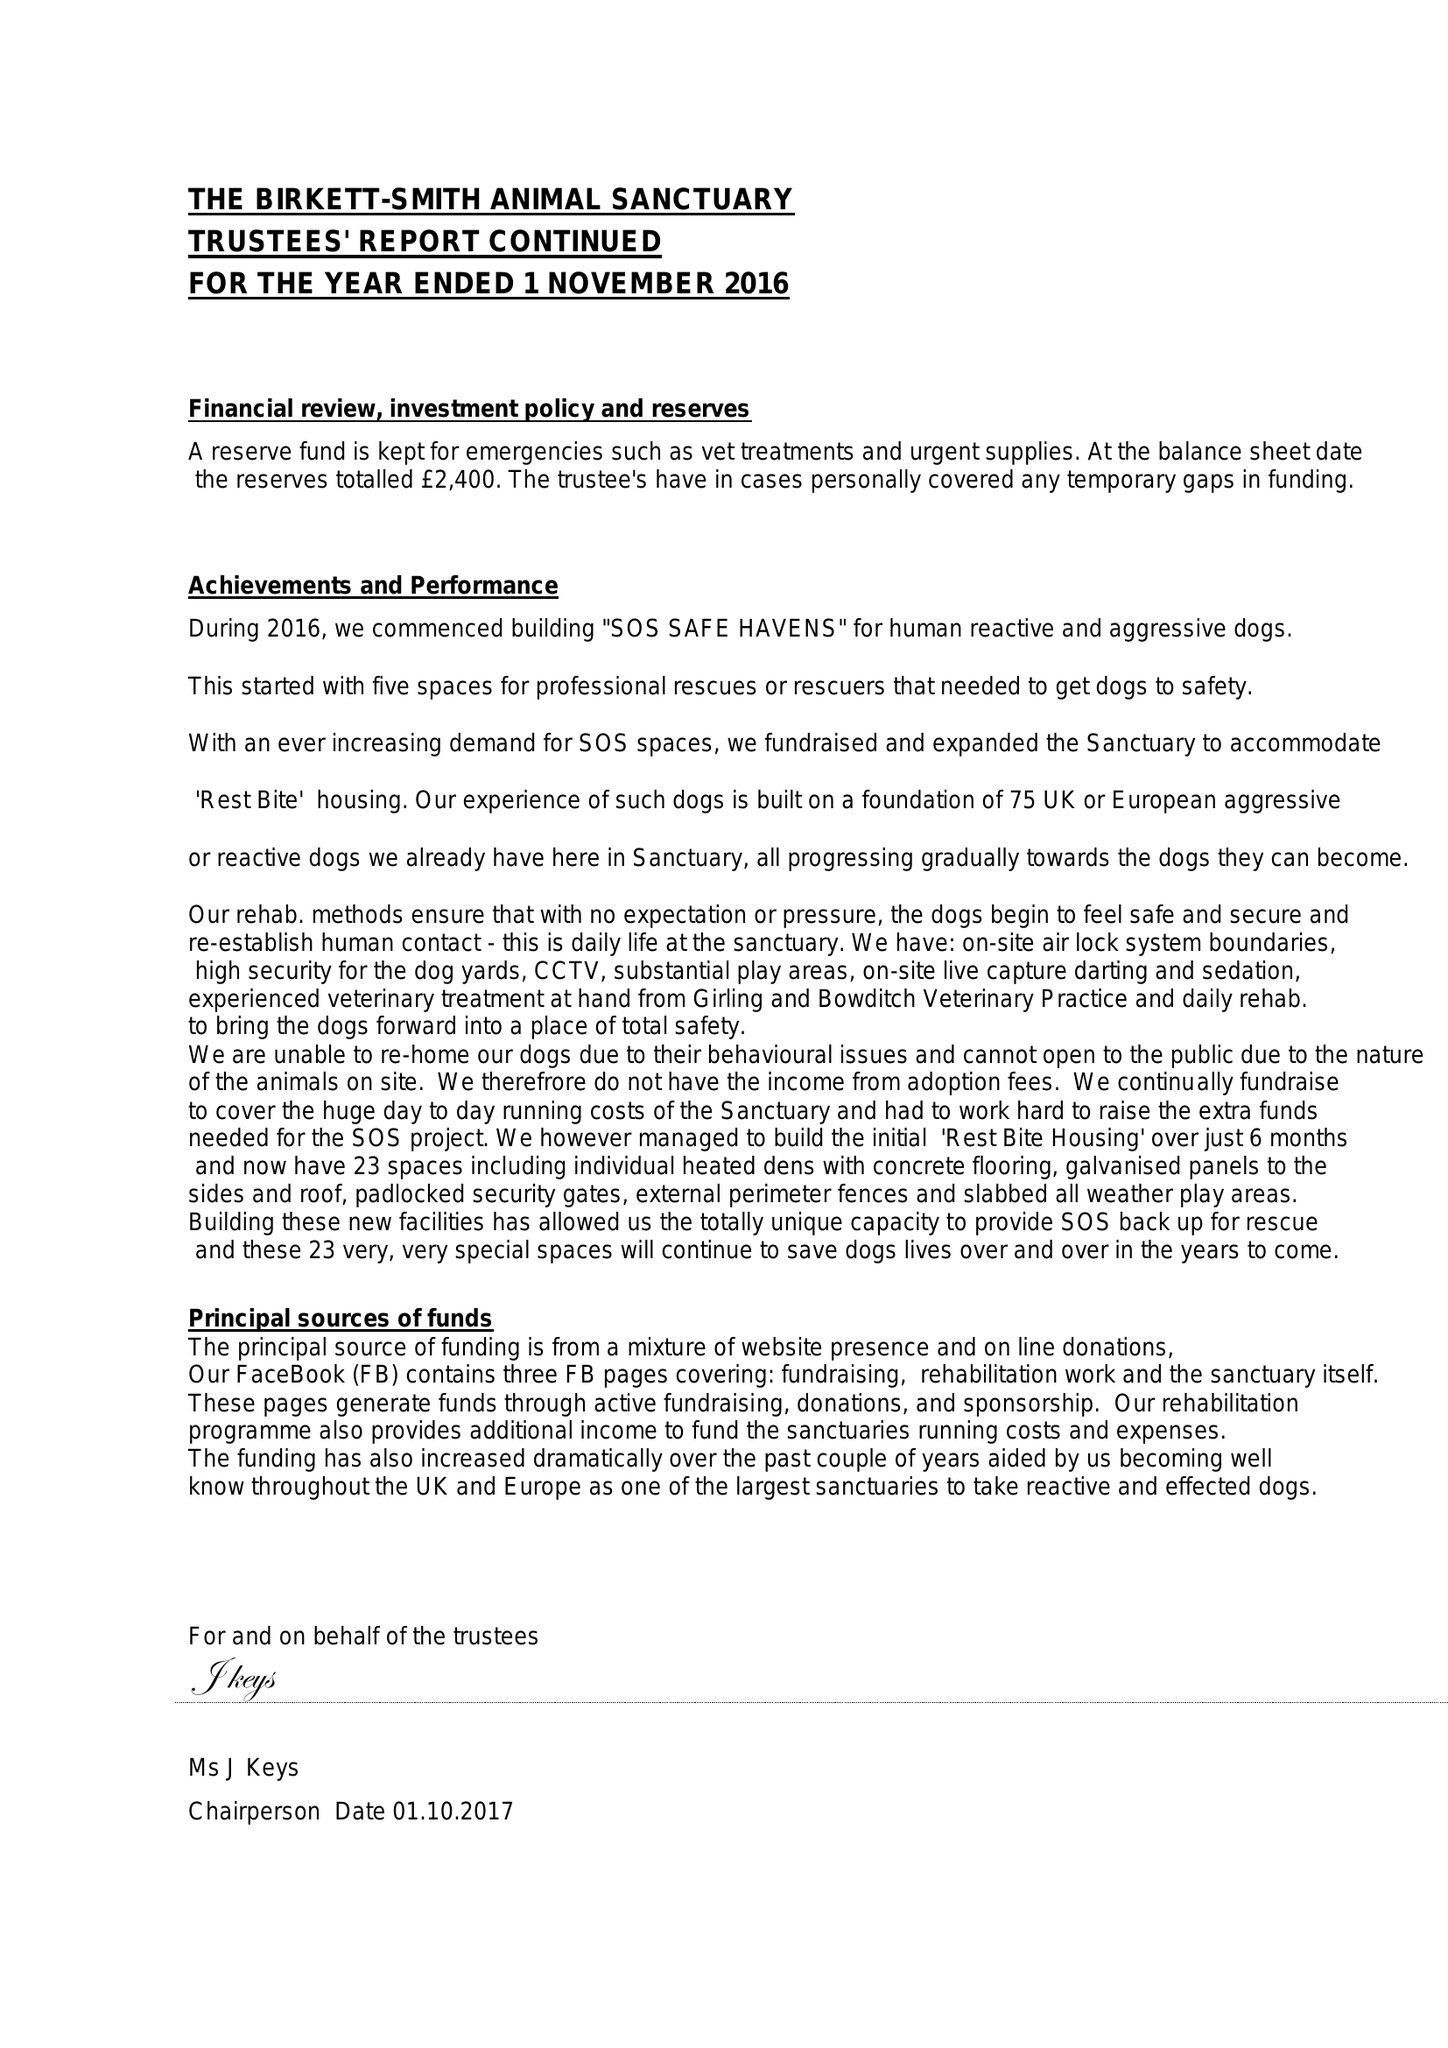What is the value for the address__postcode?
Answer the question using a single word or phrase. DT6 5NX 